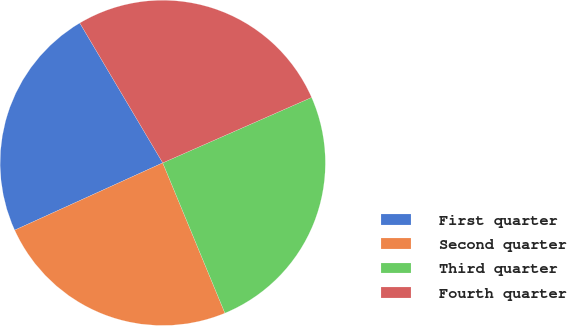Convert chart. <chart><loc_0><loc_0><loc_500><loc_500><pie_chart><fcel>First quarter<fcel>Second quarter<fcel>Third quarter<fcel>Fourth quarter<nl><fcel>23.27%<fcel>24.46%<fcel>25.35%<fcel>26.93%<nl></chart> 